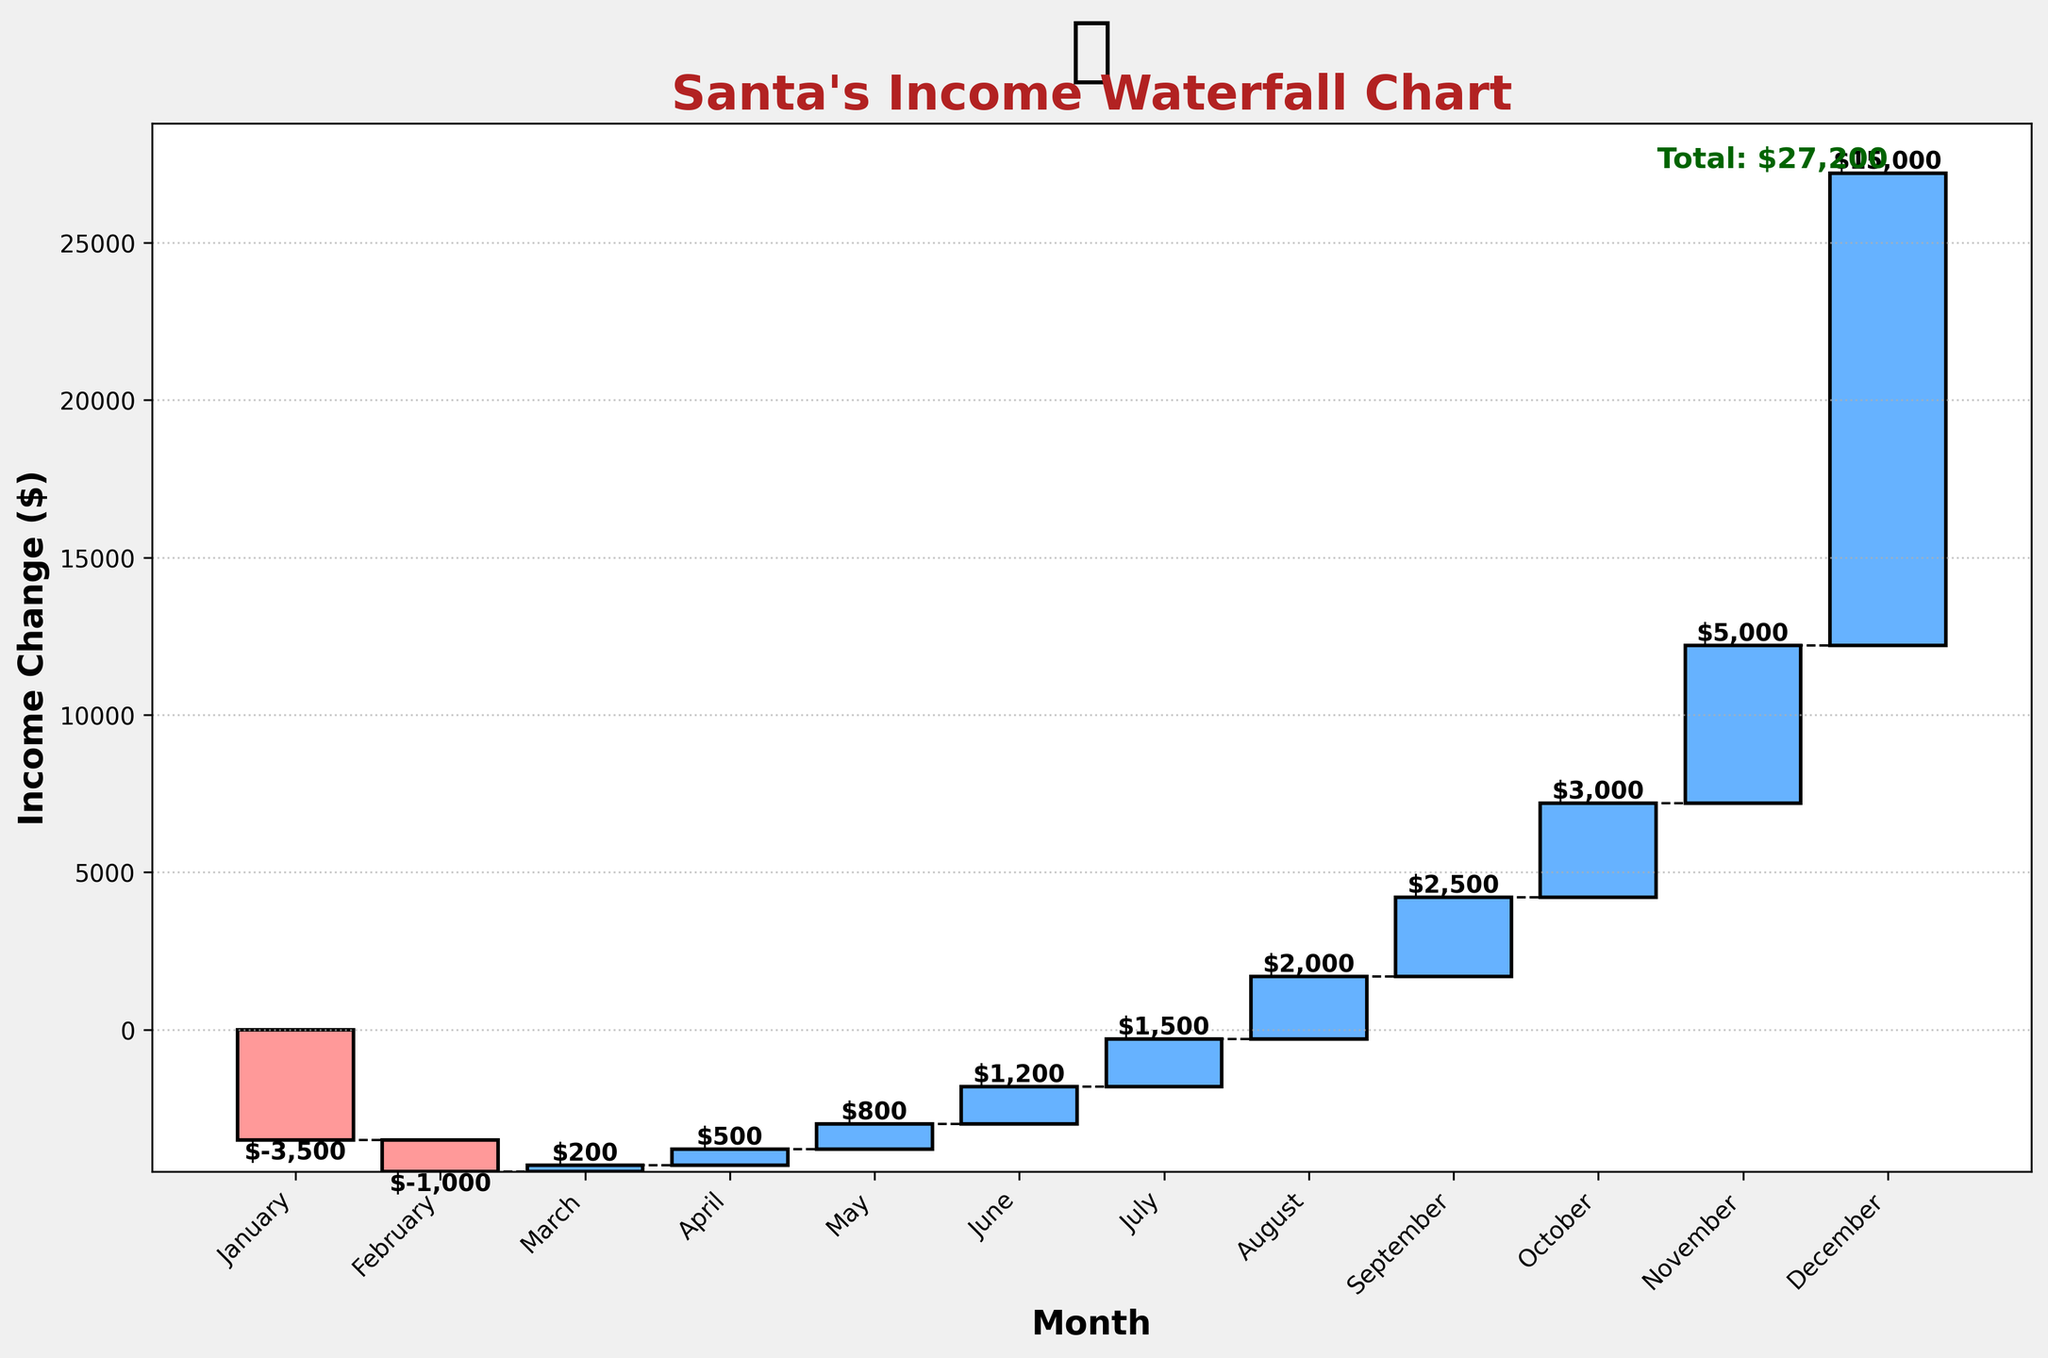What is the title of the chart? The title of the chart is located at the top, indicating the subject and nature of the chart. In this case, it reads "Santa's Income Waterfall Chart".
Answer: Santa's Income Waterfall Chart How much did the income decrease in January? By examining the bar for January, we notice the income change is a negative value of $-3500.
Answer: $-3500 Which month has the highest positive income change? Observing the heights of the bars, the tallest positive bar is in December, indicating the highest income change of $15000.
Answer: December What is the total income change by the end of the year? The total income change can be observed at the rightmost bar's label which shows "Total: $21,200".
Answer: $21,200 How does the income change from February to March? The income change in February is $-1000 and in March is $200. The difference between March and February is $200 - $(-1000) = $1200.
Answer: $1200 What is the cumulative income change just before November? To find the cumulative income change up to October, sum the changes from January to October: $-3500 + (-1000) + 200 + 500 + 800 + 1200 + 1500 + 2000 + 2500 + 3000 = $4200.
Answer: $4200 Which months have a negative income change? Negative income changes are indicated by the red bars in the chart. These occur in January and February.
Answer: January, February How does the income change in Q2 compare to Q3? Calculate Q2 (April, May, June): $500 + 800 + 1200 = $2500. Calculate Q3 (July, August, September): $1500 + 2000 + 2500 = $6000. The income change in Q3 is $6000 - $2500 = $3500 greater than in Q2.
Answer: Q3 is $3500 greater What is the difference in income change between the lowest and highest months? The lowest income change is $-3500 in January and the highest is $15000 in December. The difference is $15000 - $(-3500) = $18500.
Answer: $18500 How many months show an income increase? Positive income changes are shown by blue bars. Counting these, we see 9 months (March to December) with income increases.
Answer: 9 